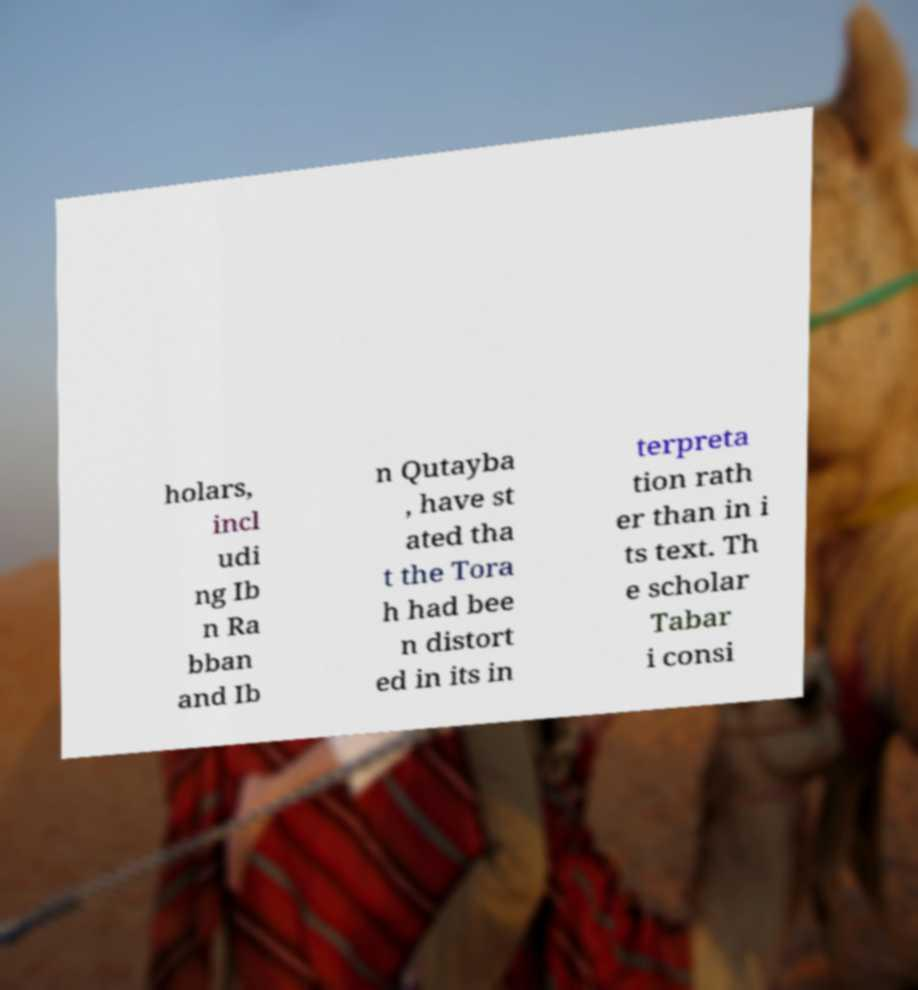For documentation purposes, I need the text within this image transcribed. Could you provide that? holars, incl udi ng Ib n Ra bban and Ib n Qutayba , have st ated tha t the Tora h had bee n distort ed in its in terpreta tion rath er than in i ts text. Th e scholar Tabar i consi 